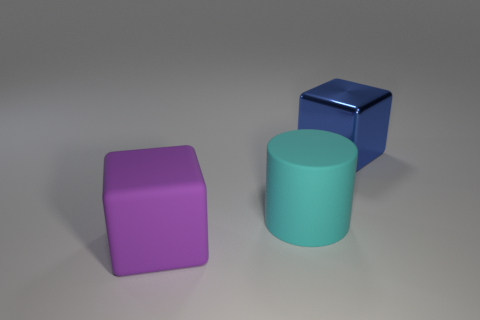Add 3 green matte cubes. How many objects exist? 6 Subtract all blue cubes. How many cubes are left? 1 Subtract all cylinders. How many objects are left? 2 Subtract 1 blocks. How many blocks are left? 1 Add 1 big cyan rubber cylinders. How many big cyan rubber cylinders are left? 2 Add 2 rubber cylinders. How many rubber cylinders exist? 3 Subtract 0 purple cylinders. How many objects are left? 3 Subtract all yellow cubes. Subtract all yellow cylinders. How many cubes are left? 2 Subtract all blue cubes. How many blue cylinders are left? 0 Subtract all large blue metallic things. Subtract all yellow metal cubes. How many objects are left? 2 